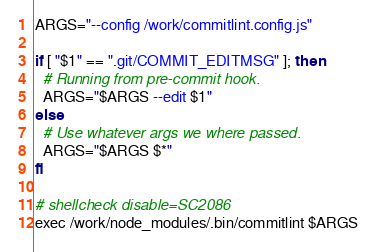<code> <loc_0><loc_0><loc_500><loc_500><_Bash_>ARGS="--config /work/commitlint.config.js"

if [ "$1" == ".git/COMMIT_EDITMSG" ]; then
  # Running from pre-commit hook.
  ARGS="$ARGS --edit $1"
else
  # Use whatever args we where passed.
  ARGS="$ARGS $*"
fi

# shellcheck disable=SC2086
exec /work/node_modules/.bin/commitlint $ARGS
</code> 